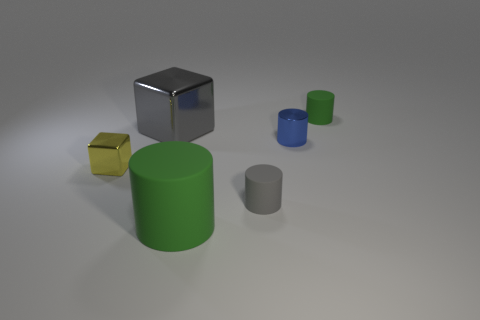Subtract all large matte cylinders. How many cylinders are left? 3 Add 2 matte objects. How many objects exist? 8 Subtract 1 cylinders. How many cylinders are left? 3 Subtract all large brown matte cylinders. Subtract all small matte things. How many objects are left? 4 Add 6 gray objects. How many gray objects are left? 8 Add 6 matte things. How many matte things exist? 9 Subtract all blue cylinders. How many cylinders are left? 3 Subtract 1 green cylinders. How many objects are left? 5 Subtract all cylinders. How many objects are left? 2 Subtract all green blocks. Subtract all blue cylinders. How many blocks are left? 2 